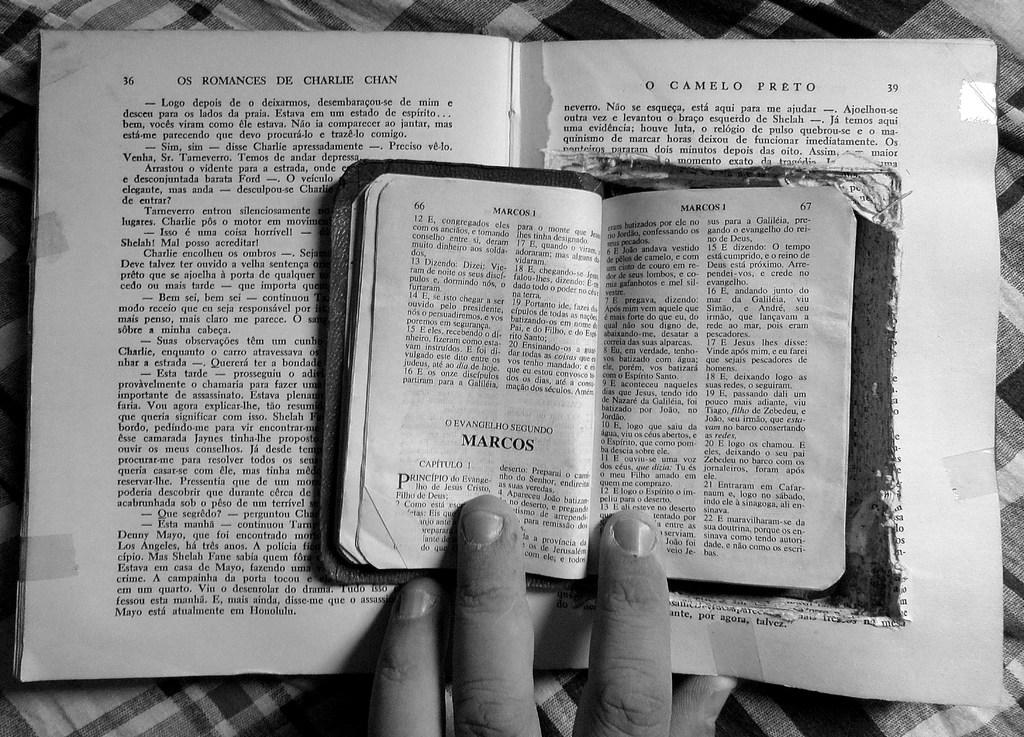<image>
Create a compact narrative representing the image presented. A book is open to page 66 and is titled Marcos. 